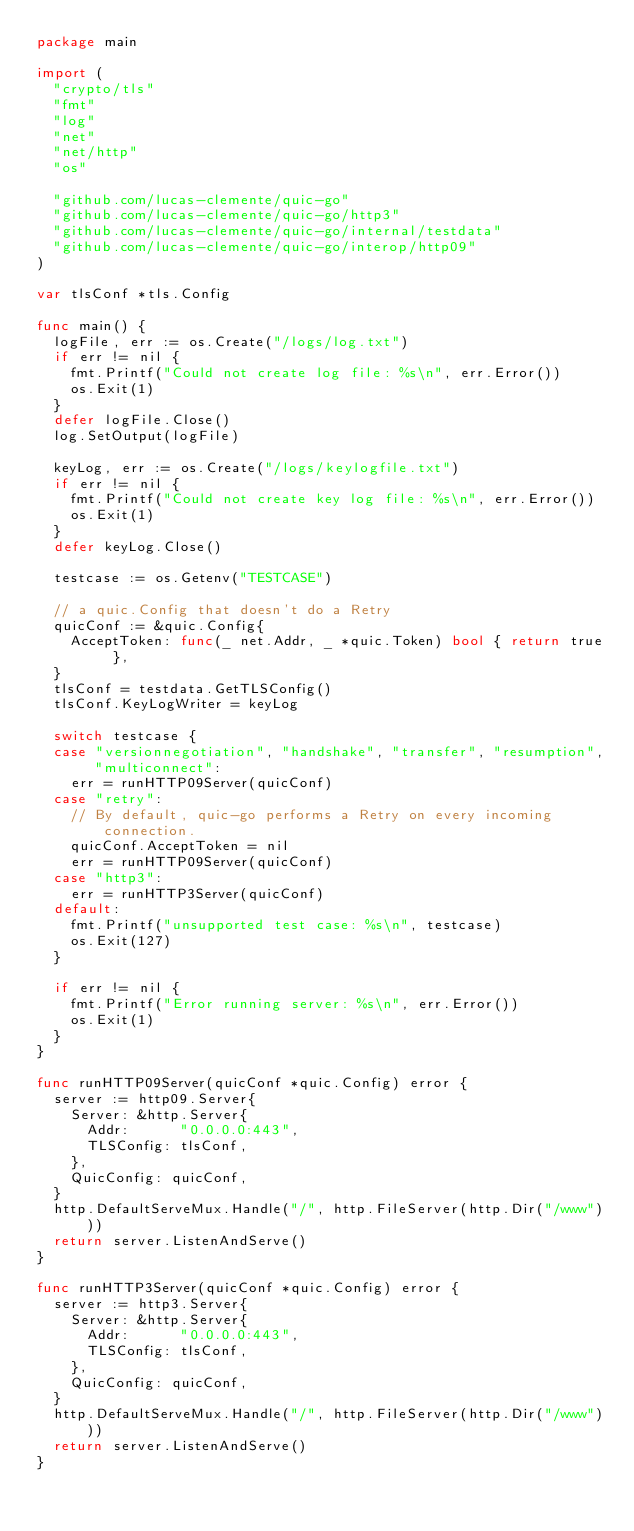<code> <loc_0><loc_0><loc_500><loc_500><_Go_>package main

import (
	"crypto/tls"
	"fmt"
	"log"
	"net"
	"net/http"
	"os"

	"github.com/lucas-clemente/quic-go"
	"github.com/lucas-clemente/quic-go/http3"
	"github.com/lucas-clemente/quic-go/internal/testdata"
	"github.com/lucas-clemente/quic-go/interop/http09"
)

var tlsConf *tls.Config

func main() {
	logFile, err := os.Create("/logs/log.txt")
	if err != nil {
		fmt.Printf("Could not create log file: %s\n", err.Error())
		os.Exit(1)
	}
	defer logFile.Close()
	log.SetOutput(logFile)

	keyLog, err := os.Create("/logs/keylogfile.txt")
	if err != nil {
		fmt.Printf("Could not create key log file: %s\n", err.Error())
		os.Exit(1)
	}
	defer keyLog.Close()

	testcase := os.Getenv("TESTCASE")

	// a quic.Config that doesn't do a Retry
	quicConf := &quic.Config{
		AcceptToken: func(_ net.Addr, _ *quic.Token) bool { return true },
	}
	tlsConf = testdata.GetTLSConfig()
	tlsConf.KeyLogWriter = keyLog

	switch testcase {
	case "versionnegotiation", "handshake", "transfer", "resumption", "multiconnect":
		err = runHTTP09Server(quicConf)
	case "retry":
		// By default, quic-go performs a Retry on every incoming connection.
		quicConf.AcceptToken = nil
		err = runHTTP09Server(quicConf)
	case "http3":
		err = runHTTP3Server(quicConf)
	default:
		fmt.Printf("unsupported test case: %s\n", testcase)
		os.Exit(127)
	}

	if err != nil {
		fmt.Printf("Error running server: %s\n", err.Error())
		os.Exit(1)
	}
}

func runHTTP09Server(quicConf *quic.Config) error {
	server := http09.Server{
		Server: &http.Server{
			Addr:      "0.0.0.0:443",
			TLSConfig: tlsConf,
		},
		QuicConfig: quicConf,
	}
	http.DefaultServeMux.Handle("/", http.FileServer(http.Dir("/www")))
	return server.ListenAndServe()
}

func runHTTP3Server(quicConf *quic.Config) error {
	server := http3.Server{
		Server: &http.Server{
			Addr:      "0.0.0.0:443",
			TLSConfig: tlsConf,
		},
		QuicConfig: quicConf,
	}
	http.DefaultServeMux.Handle("/", http.FileServer(http.Dir("/www")))
	return server.ListenAndServe()
}
</code> 